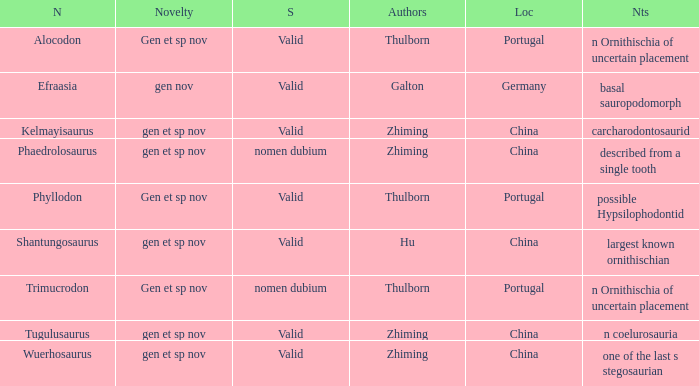What is the Novelty of the dinosaur that was named by the Author, Zhiming, and whose Notes are, "carcharodontosaurid"? Gen et sp nov. 